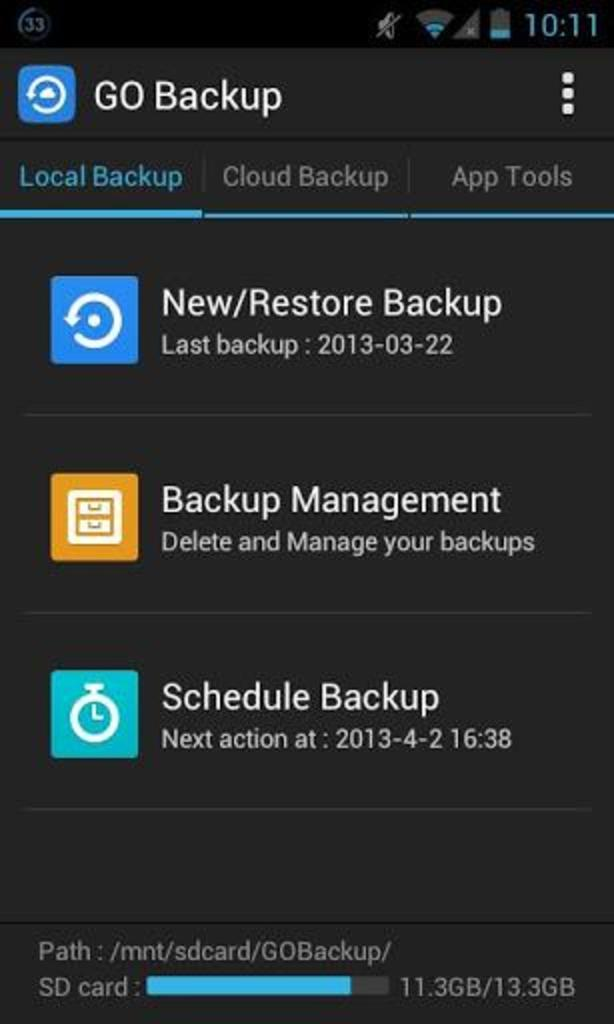<image>
Render a clear and concise summary of the photo. a phone page that says go backup on it 